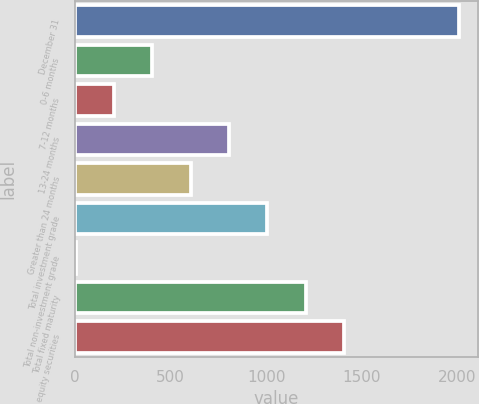Convert chart. <chart><loc_0><loc_0><loc_500><loc_500><bar_chart><fcel>December 31<fcel>0-6 months<fcel>7-12 months<fcel>13-24 months<fcel>Greater than 24 months<fcel>Total investment grade<fcel>Total non-investment grade<fcel>Total fixed maturity<fcel>equity securities<nl><fcel>2006<fcel>404.4<fcel>204.2<fcel>804.8<fcel>604.6<fcel>1005<fcel>4<fcel>1205.2<fcel>1405.4<nl></chart> 